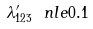Convert formula to latex. <formula><loc_0><loc_0><loc_500><loc_500>\lambda ^ { \prime } _ { 1 2 3 } \ n l e 0 . 1</formula> 